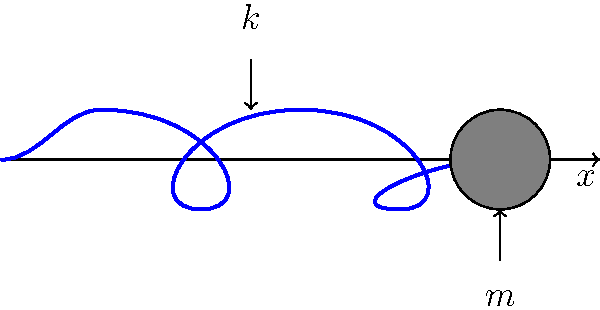In a spring-mass system, a mass of 2 kg is attached to a spring with a spring constant of 100 N/m. What is the natural frequency of this system in Hz? To determine the natural frequency of a spring-mass system, we follow these steps:

1. Recall the formula for natural frequency (in radians per second):
   $$\omega_n = \sqrt{\frac{k}{m}}$$
   where $k$ is the spring constant and $m$ is the mass.

2. Substitute the given values:
   $k = 100$ N/m
   $m = 2$ kg

3. Calculate $\omega_n$:
   $$\omega_n = \sqrt{\frac{100}{2}} = \sqrt{50} = 7.071 \text{ rad/s}$$

4. Convert from radians per second to Hz:
   $$f_n = \frac{\omega_n}{2\pi} = \frac{7.071}{2\pi} = 1.125 \text{ Hz}$$

5. Round to three decimal places:
   $$f_n \approx 1.125 \text{ Hz}$$
Answer: 1.125 Hz 